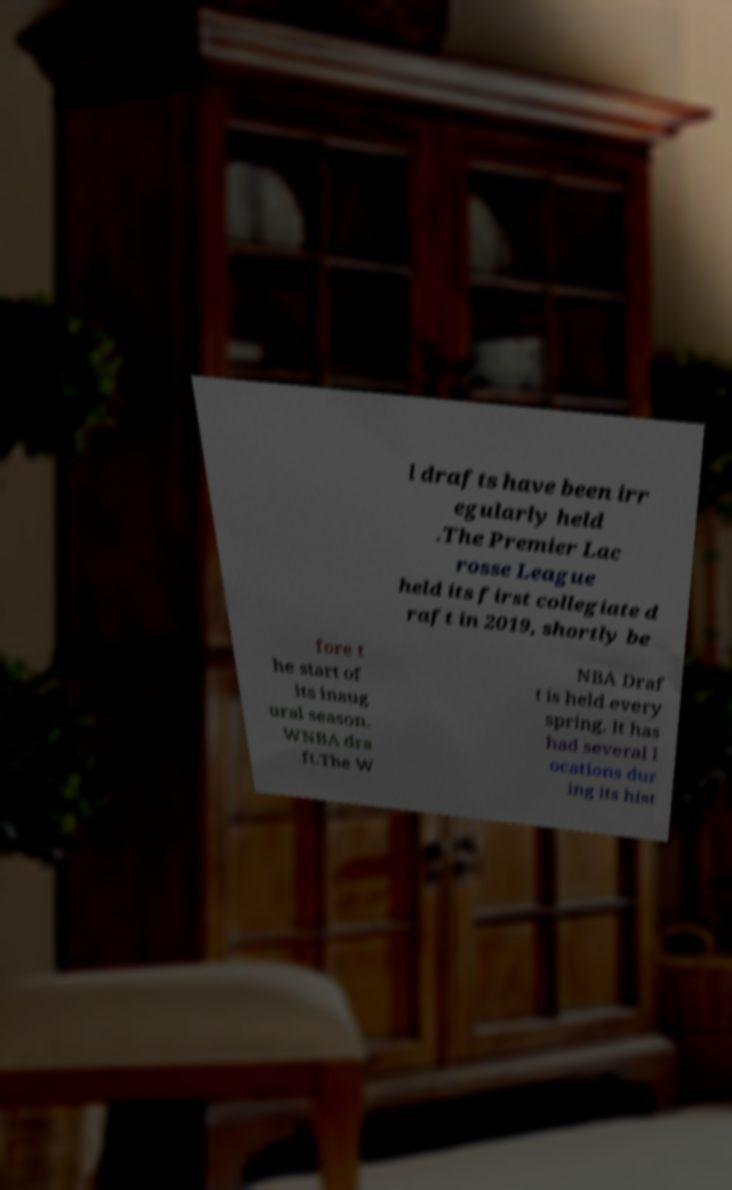Can you read and provide the text displayed in the image?This photo seems to have some interesting text. Can you extract and type it out for me? l drafts have been irr egularly held .The Premier Lac rosse League held its first collegiate d raft in 2019, shortly be fore t he start of its inaug ural season. WNBA dra ft.The W NBA Draf t is held every spring. It has had several l ocations dur ing its hist 